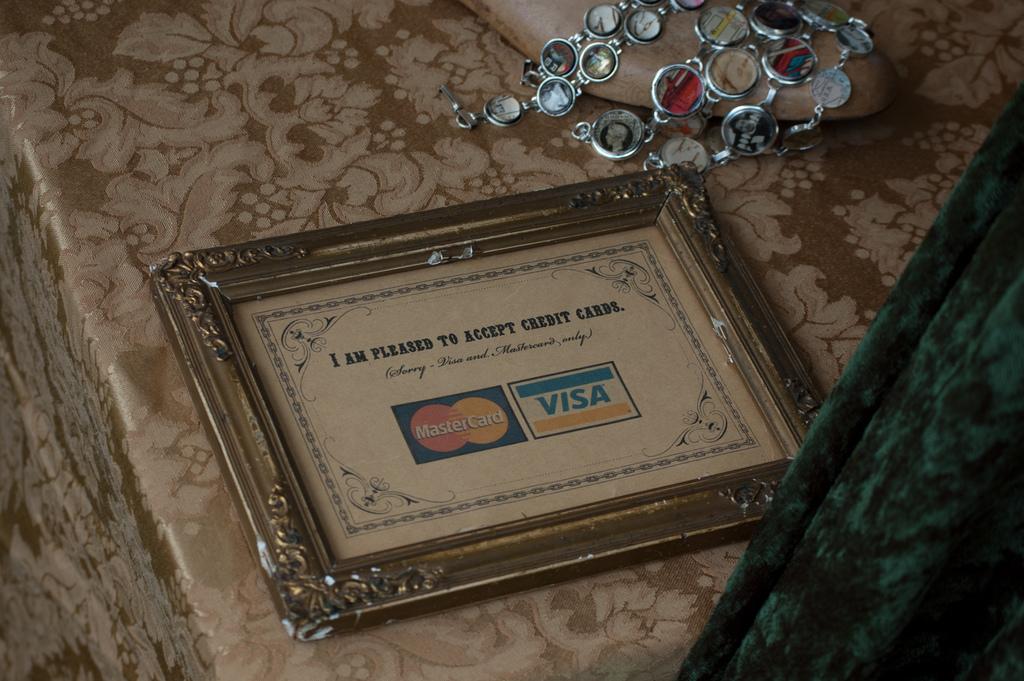What do they accept?
Make the answer very short. Credit cards. What surrounds the picture?
Your answer should be very brief. Answering does not require reading text in the image. 